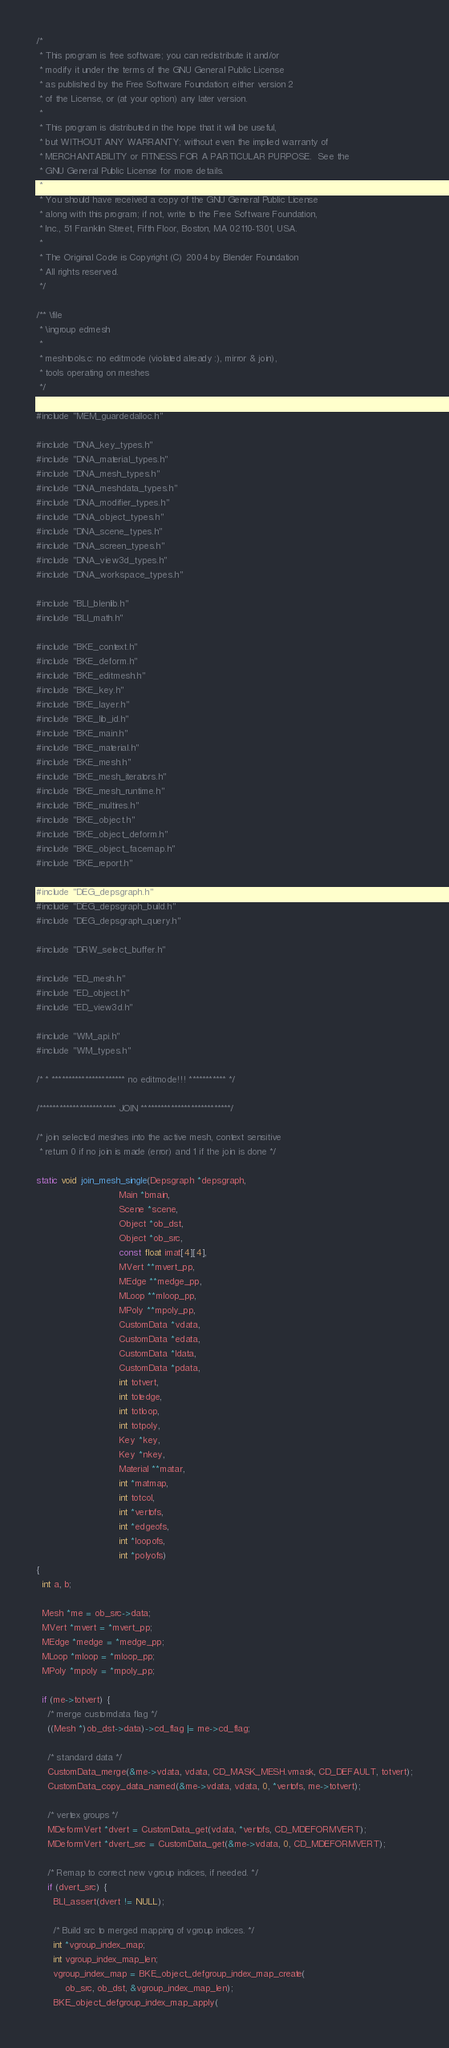<code> <loc_0><loc_0><loc_500><loc_500><_C_>/*
 * This program is free software; you can redistribute it and/or
 * modify it under the terms of the GNU General Public License
 * as published by the Free Software Foundation; either version 2
 * of the License, or (at your option) any later version.
 *
 * This program is distributed in the hope that it will be useful,
 * but WITHOUT ANY WARRANTY; without even the implied warranty of
 * MERCHANTABILITY or FITNESS FOR A PARTICULAR PURPOSE.  See the
 * GNU General Public License for more details.
 *
 * You should have received a copy of the GNU General Public License
 * along with this program; if not, write to the Free Software Foundation,
 * Inc., 51 Franklin Street, Fifth Floor, Boston, MA 02110-1301, USA.
 *
 * The Original Code is Copyright (C) 2004 by Blender Foundation
 * All rights reserved.
 */

/** \file
 * \ingroup edmesh
 *
 * meshtools.c: no editmode (violated already :), mirror & join),
 * tools operating on meshes
 */

#include "MEM_guardedalloc.h"

#include "DNA_key_types.h"
#include "DNA_material_types.h"
#include "DNA_mesh_types.h"
#include "DNA_meshdata_types.h"
#include "DNA_modifier_types.h"
#include "DNA_object_types.h"
#include "DNA_scene_types.h"
#include "DNA_screen_types.h"
#include "DNA_view3d_types.h"
#include "DNA_workspace_types.h"

#include "BLI_blenlib.h"
#include "BLI_math.h"

#include "BKE_context.h"
#include "BKE_deform.h"
#include "BKE_editmesh.h"
#include "BKE_key.h"
#include "BKE_layer.h"
#include "BKE_lib_id.h"
#include "BKE_main.h"
#include "BKE_material.h"
#include "BKE_mesh.h"
#include "BKE_mesh_iterators.h"
#include "BKE_mesh_runtime.h"
#include "BKE_multires.h"
#include "BKE_object.h"
#include "BKE_object_deform.h"
#include "BKE_object_facemap.h"
#include "BKE_report.h"

#include "DEG_depsgraph.h"
#include "DEG_depsgraph_build.h"
#include "DEG_depsgraph_query.h"

#include "DRW_select_buffer.h"

#include "ED_mesh.h"
#include "ED_object.h"
#include "ED_view3d.h"

#include "WM_api.h"
#include "WM_types.h"

/* * ********************** no editmode!!! *********** */

/*********************** JOIN ***************************/

/* join selected meshes into the active mesh, context sensitive
 * return 0 if no join is made (error) and 1 if the join is done */

static void join_mesh_single(Depsgraph *depsgraph,
                             Main *bmain,
                             Scene *scene,
                             Object *ob_dst,
                             Object *ob_src,
                             const float imat[4][4],
                             MVert **mvert_pp,
                             MEdge **medge_pp,
                             MLoop **mloop_pp,
                             MPoly **mpoly_pp,
                             CustomData *vdata,
                             CustomData *edata,
                             CustomData *ldata,
                             CustomData *pdata,
                             int totvert,
                             int totedge,
                             int totloop,
                             int totpoly,
                             Key *key,
                             Key *nkey,
                             Material **matar,
                             int *matmap,
                             int totcol,
                             int *vertofs,
                             int *edgeofs,
                             int *loopofs,
                             int *polyofs)
{
  int a, b;

  Mesh *me = ob_src->data;
  MVert *mvert = *mvert_pp;
  MEdge *medge = *medge_pp;
  MLoop *mloop = *mloop_pp;
  MPoly *mpoly = *mpoly_pp;

  if (me->totvert) {
    /* merge customdata flag */
    ((Mesh *)ob_dst->data)->cd_flag |= me->cd_flag;

    /* standard data */
    CustomData_merge(&me->vdata, vdata, CD_MASK_MESH.vmask, CD_DEFAULT, totvert);
    CustomData_copy_data_named(&me->vdata, vdata, 0, *vertofs, me->totvert);

    /* vertex groups */
    MDeformVert *dvert = CustomData_get(vdata, *vertofs, CD_MDEFORMVERT);
    MDeformVert *dvert_src = CustomData_get(&me->vdata, 0, CD_MDEFORMVERT);

    /* Remap to correct new vgroup indices, if needed. */
    if (dvert_src) {
      BLI_assert(dvert != NULL);

      /* Build src to merged mapping of vgroup indices. */
      int *vgroup_index_map;
      int vgroup_index_map_len;
      vgroup_index_map = BKE_object_defgroup_index_map_create(
          ob_src, ob_dst, &vgroup_index_map_len);
      BKE_object_defgroup_index_map_apply(</code> 